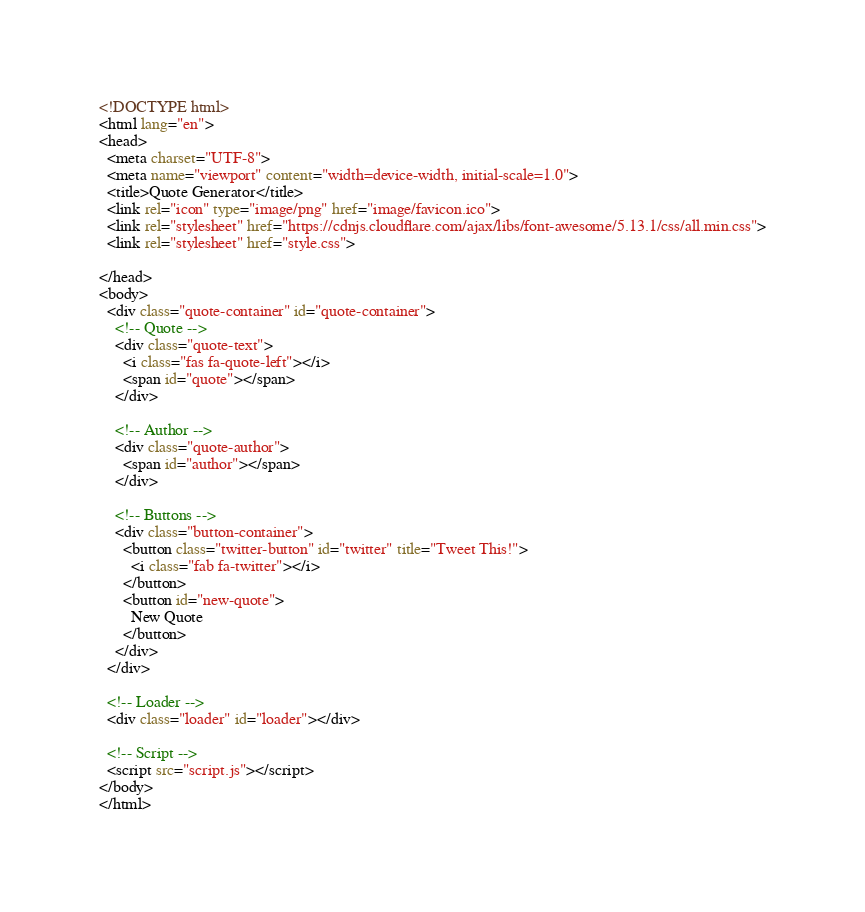<code> <loc_0><loc_0><loc_500><loc_500><_HTML_><!DOCTYPE html>
<html lang="en">
<head>
  <meta charset="UTF-8">
  <meta name="viewport" content="width=device-width, initial-scale=1.0">
  <title>Quote Generator</title>
  <link rel="icon" type="image/png" href="image/favicon.ico">
  <link rel="stylesheet" href="https://cdnjs.cloudflare.com/ajax/libs/font-awesome/5.13.1/css/all.min.css">
  <link rel="stylesheet" href="style.css">
  
</head>
<body>
  <div class="quote-container" id="quote-container">
    <!-- Quote -->
    <div class="quote-text">
      <i class="fas fa-quote-left"></i>
      <span id="quote"></span>
    </div>
    
    <!-- Author -->
    <div class="quote-author">
      <span id="author"></span>
    </div>
    
    <!-- Buttons -->
    <div class="button-container">
      <button class="twitter-button" id="twitter" title="Tweet This!">
        <i class="fab fa-twitter"></i>
      </button>
      <button id="new-quote">
        New Quote
      </button>
    </div>
  </div>

  <!-- Loader -->
  <div class="loader" id="loader"></div>

  <!-- Script -->
  <script src="script.js"></script>
</body>
</html></code> 